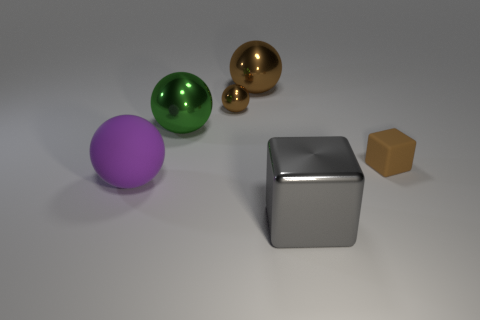What is the size of the rubber object on the right side of the matte sphere?
Your answer should be very brief. Small. Is there a big shiny object of the same color as the tiny metal thing?
Give a very brief answer. Yes. There is a tiny ball that is the same color as the small block; what is it made of?
Give a very brief answer. Metal. There is a cube that is behind the big gray metallic object; is it the same size as the shiny thing that is behind the small brown sphere?
Make the answer very short. No. What size is the matte cube that is the same color as the small metal ball?
Your response must be concise. Small. Is the color of the tiny shiny sphere the same as the matte block?
Your answer should be compact. Yes. Is there anything else of the same color as the tiny matte object?
Your answer should be very brief. Yes. What shape is the large metal thing in front of the purple object?
Your response must be concise. Cube. Is the color of the small thing that is to the left of the small brown cube the same as the tiny thing that is to the right of the large gray cube?
Offer a very short reply. Yes. How many large metal objects are both in front of the tiny metal thing and behind the big rubber sphere?
Give a very brief answer. 1. 